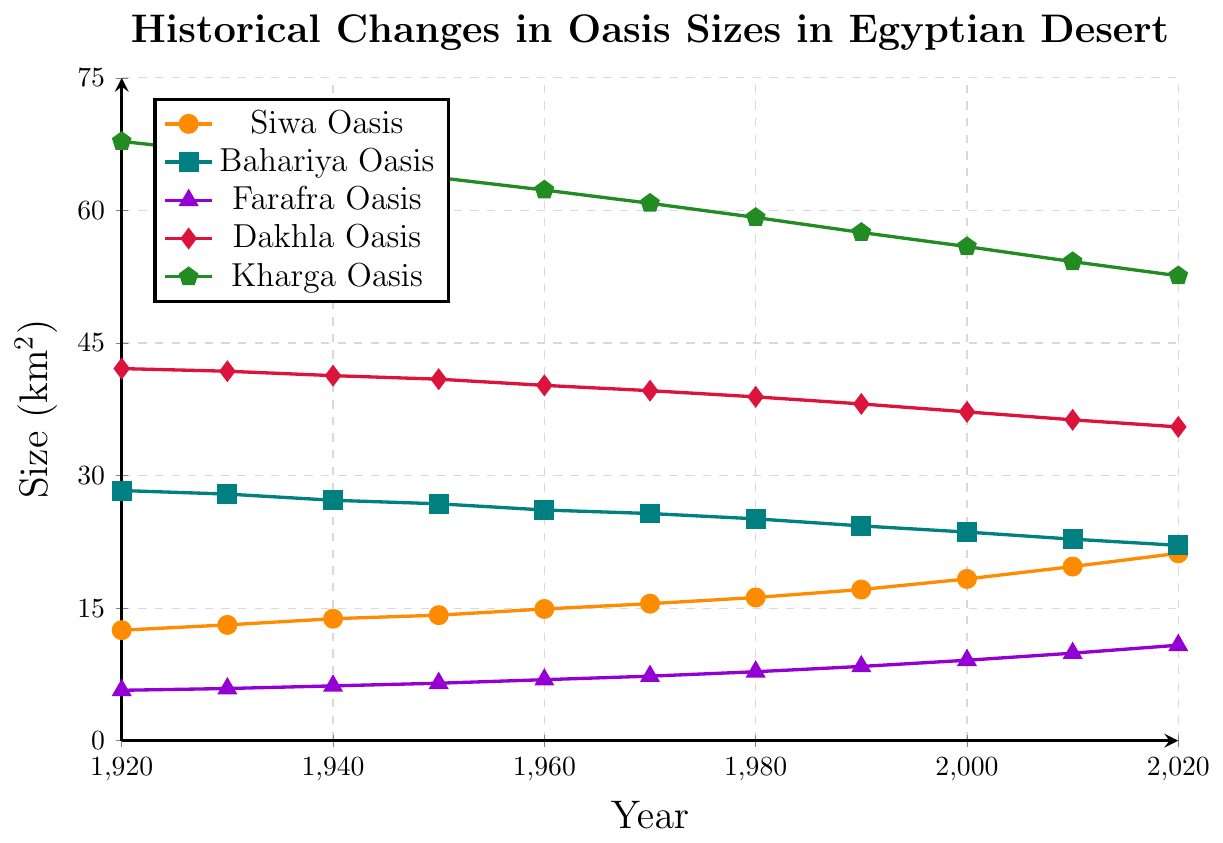What was the size of the Siwa Oasis in 1970? Locate the point for Siwa Oasis in the year 1970 on the graph. The y-coordinate corresponds to the size.
Answer: 15.5 km² Which oasis experienced the largest decrease in size from 1920 to 2020? Calculate the size difference between 1920 and 2020 for each oasis, then compare them. Kharga Oasis decreased from 67.8 km² to 52.6 km², which is the largest difference.
Answer: Kharga Oasis How did the size of Farafra Oasis change on average every decade? Calculate the total change in size of Farafra Oasis from 1920 to 2020, then divide by the number of decades. The change is 10.8 - 5.7 = 5.1 km² over 10 decades, so 5.1 ÷ 10 = 0.51 km² per decade.
Answer: 0.51 km² In which decade did Bahariya Oasis see the greatest decline in size? Calculate the size difference for each decade for Bahariya Oasis, then identify the decade with the largest decline. Between 1940 and 1950, the decrease is from 27.2 km² to 26.8 km².
Answer: 1940-1950 Compare the sizes of Dakhla and Kharga Oases in 1960. Which was larger and by how much? Locate the points for Dakhla and Kharga Oases in 1960. The sizes are 40.2 km² and 62.3 km², respectively. Subtract the size of Dakhla from Kharga: 62.3 - 40.2 = 22.1 km².
Answer: Kharga Oasis by 22.1 km² What was the overall trend in the size of the Siwa Oasis from 1920 to 2020? Observe the line representing Siwa Oasis from 1920 to 2020. The size consistently increases over the century.
Answer: Increasing How does the size of Bahariya Oasis in 2020 compare to its size in 1980? Locate the sizes of Bahariya Oasis in 1980 and 2020, then compare them. The sizes are 25.1 km² in 1980 and 22.1 km² in 2020.
Answer: Decrease by 3 km² Which oasis had the smallest size in 1940? Identify the points for all oases in 1940, then find the smallest value. Farafra Oasis had the smallest size with 6.2 km².
Answer: Farafra Oasis What is the combined size of Siwa and Farafra Oases in 2020? Add the sizes of Siwa and Farafra Oases in 2020: 21.2 km² + 10.8 km².
Answer: 32 km² Which oasis showed an overall decreasing trend in size from 1920 to 2020? Observe the lines representing each oasis from 1920 to 2020 and identify those with a declining slope. Both Bahariya, Dakhla, and Kharga Oases show decreasing trends.
Answer: Bahariya, Dakhla, and Kharga Oases 